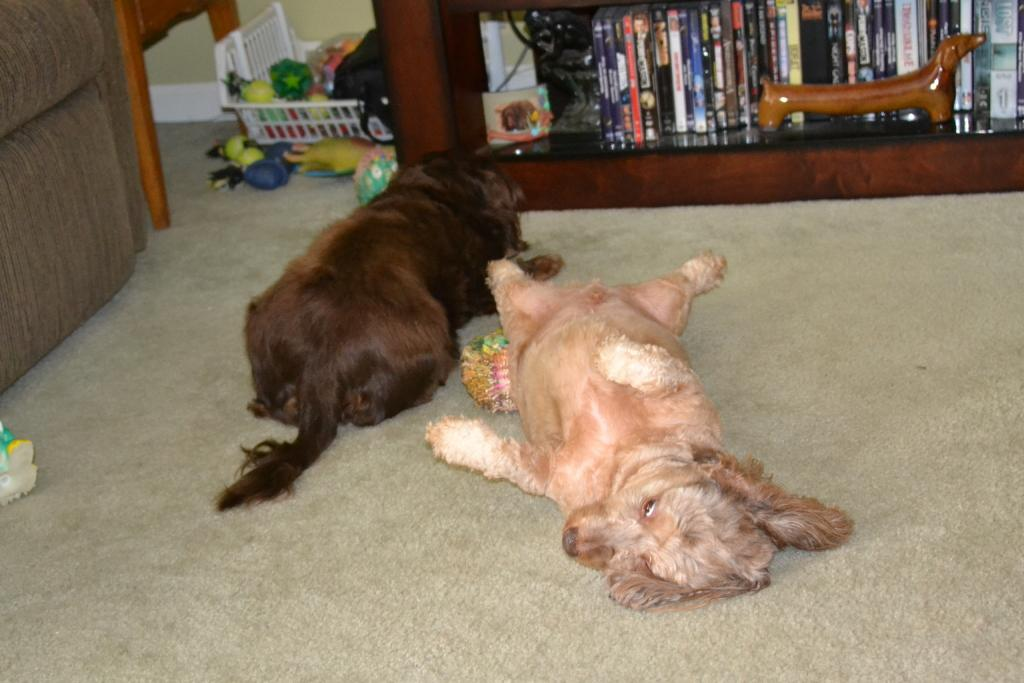What animals are lying on the carpet in the image? There are two dogs lying on a carpet in the image. What can be seen behind the dogs? There are many toys in a tray behind the dogs. What is located on the right side of the image? There is a shelf with a lot of books on the right side of the image. How does the elbow of the dog on the left help it play with the toys? There is no dog's elbow visible in the image, as dogs do not have elbows like humans. 